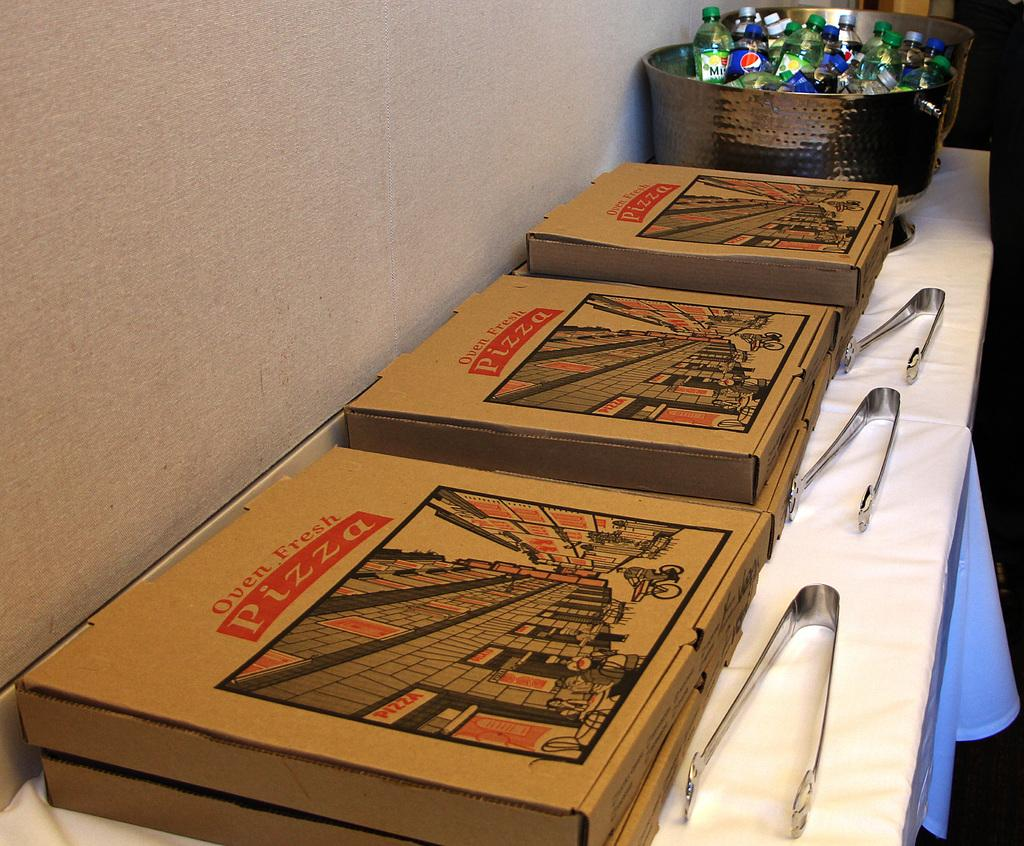<image>
Share a concise interpretation of the image provided. A pizza box claims that the pizza is oven fresh. 